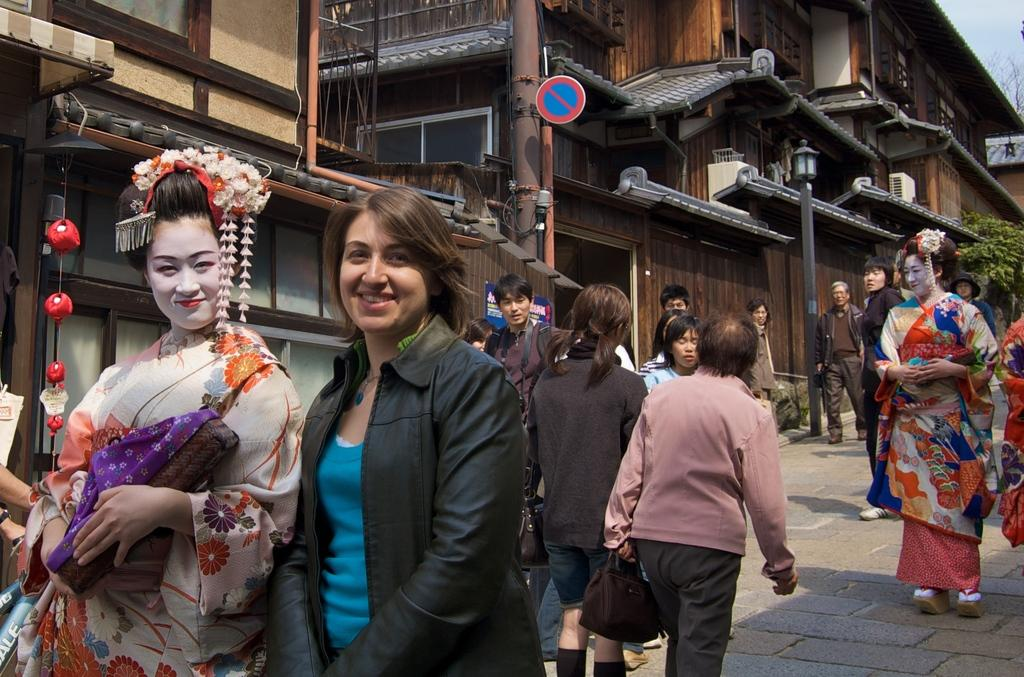What are the people in the image doing? The people in the image are walking on the road. What can be seen in the background of the image? There are buildings, trees, a pole with a sign board, and the sky visible in the background. How many elements can be identified in the background of the image? There are five elements in the background: buildings, trees, a pole with a sign board, and the sky. How many cherries are hanging from the trees in the image? There are no cherries visible in the image; only trees can be seen in the background. What type of shame can be observed in the image? There is no shame present in the image; it features people walking on the road and elements in the background. 